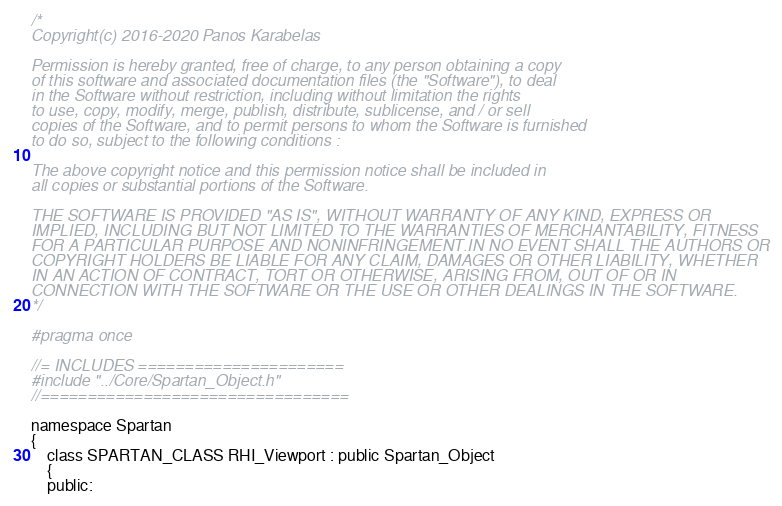Convert code to text. <code><loc_0><loc_0><loc_500><loc_500><_C_>/*
Copyright(c) 2016-2020 Panos Karabelas

Permission is hereby granted, free of charge, to any person obtaining a copy
of this software and associated documentation files (the "Software"), to deal
in the Software without restriction, including without limitation the rights
to use, copy, modify, merge, publish, distribute, sublicense, and / or sell
copies of the Software, and to permit persons to whom the Software is furnished
to do so, subject to the following conditions :

The above copyright notice and this permission notice shall be included in
all copies or substantial portions of the Software.

THE SOFTWARE IS PROVIDED "AS IS", WITHOUT WARRANTY OF ANY KIND, EXPRESS OR
IMPLIED, INCLUDING BUT NOT LIMITED TO THE WARRANTIES OF MERCHANTABILITY, FITNESS
FOR A PARTICULAR PURPOSE AND NONINFRINGEMENT.IN NO EVENT SHALL THE AUTHORS OR
COPYRIGHT HOLDERS BE LIABLE FOR ANY CLAIM, DAMAGES OR OTHER LIABILITY, WHETHER
IN AN ACTION OF CONTRACT, TORT OR OTHERWISE, ARISING FROM, OUT OF OR IN
CONNECTION WITH THE SOFTWARE OR THE USE OR OTHER DEALINGS IN THE SOFTWARE.
*/

#pragma once

//= INCLUDES ======================
#include "../Core/Spartan_Object.h"
//=================================

namespace Spartan
{
    class SPARTAN_CLASS RHI_Viewport : public Spartan_Object
    {
    public:</code> 